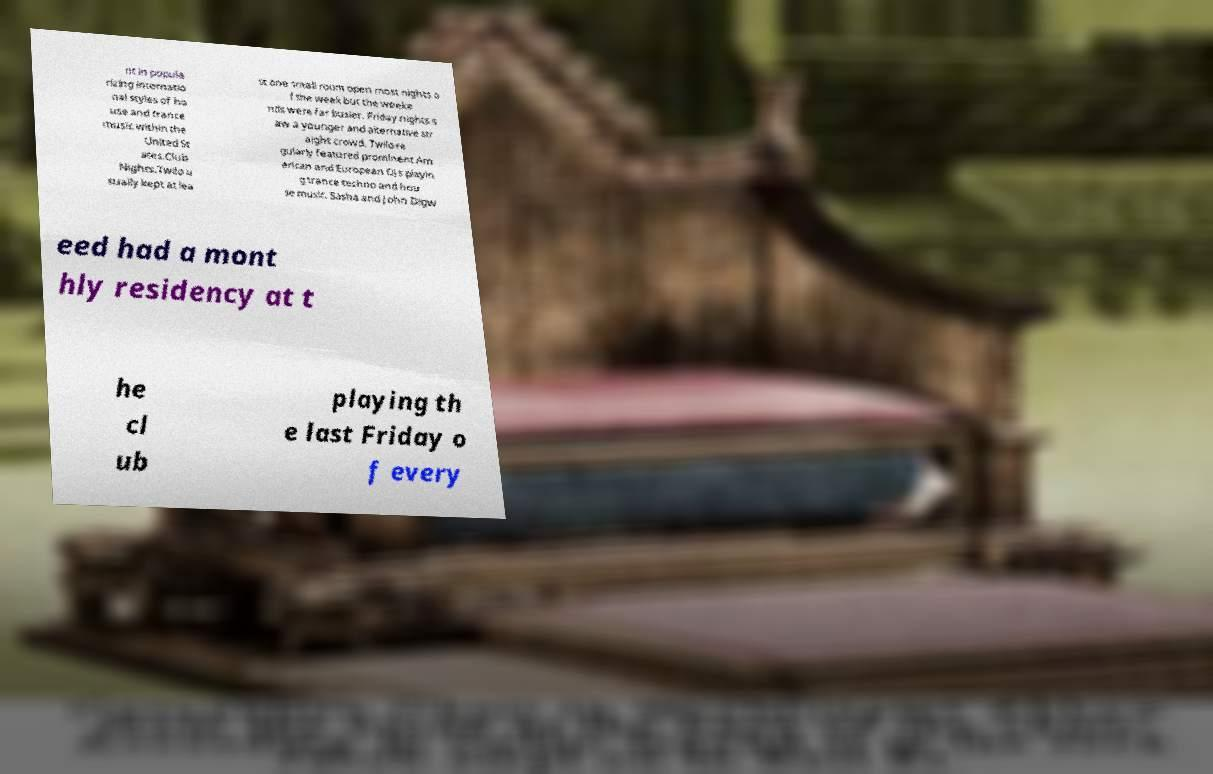There's text embedded in this image that I need extracted. Can you transcribe it verbatim? nt in popula rizing internatio nal styles of ho use and trance music within the United St ates.Club Nights.Twilo u sually kept at lea st one small room open most nights o f the week but the weeke nds were far busier. Friday nights s aw a younger and alternative str aight crowd. Twilo re gularly featured prominent Am erican and European DJs playin g trance techno and hou se music. Sasha and John Digw eed had a mont hly residency at t he cl ub playing th e last Friday o f every 